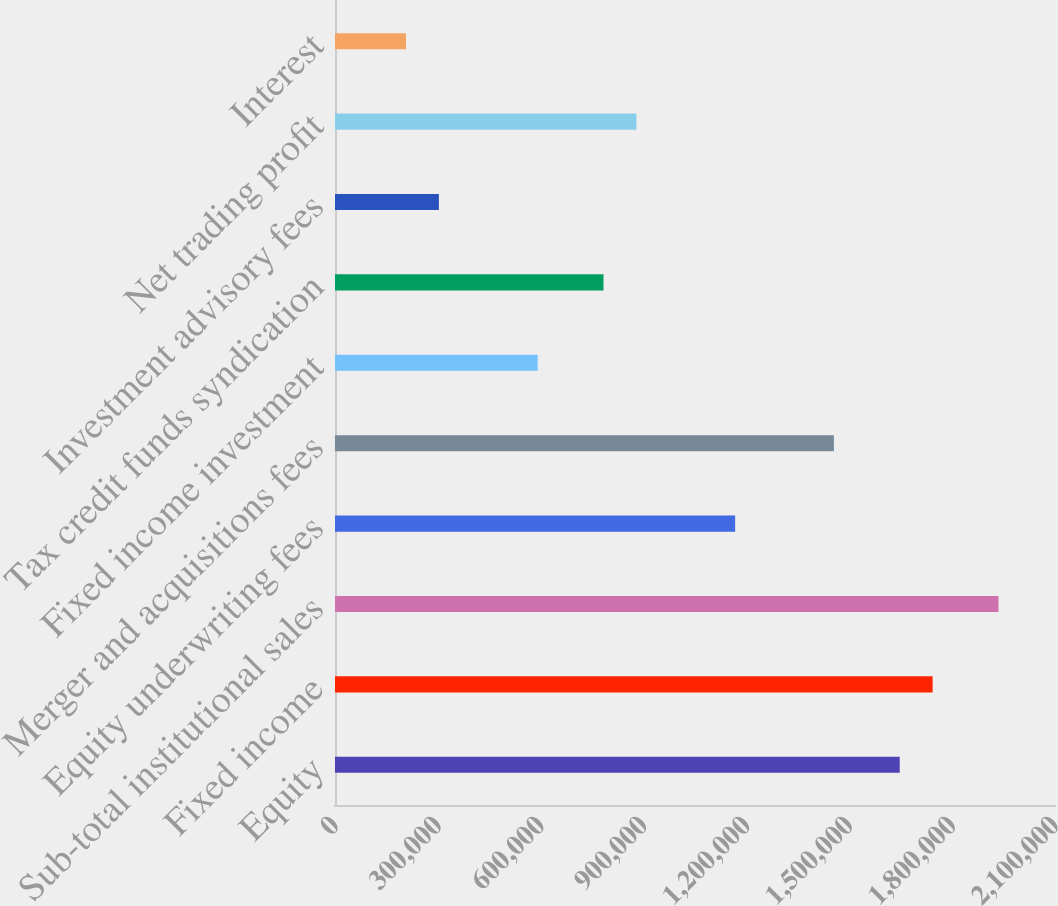Convert chart to OTSL. <chart><loc_0><loc_0><loc_500><loc_500><bar_chart><fcel>Equity<fcel>Fixed income<fcel>Sub-total institutional sales<fcel>Equity underwriting fees<fcel>Merger and acquisitions fees<fcel>Fixed income investment<fcel>Tax credit funds syndication<fcel>Investment advisory fees<fcel>Net trading profit<fcel>Interest<nl><fcel>1.64709e+06<fcel>1.74309e+06<fcel>1.9351e+06<fcel>1.16707e+06<fcel>1.45508e+06<fcel>591050<fcel>783057<fcel>303040<fcel>879060<fcel>207036<nl></chart> 